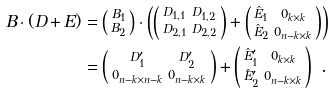Convert formula to latex. <formula><loc_0><loc_0><loc_500><loc_500>B \cdot ( D + E ) & = \left ( \begin{smallmatrix} B _ { 1 } \\ B _ { 2 } \end{smallmatrix} \right ) \cdot \left ( \left ( \begin{smallmatrix} D _ { 1 , 1 } & D _ { 1 , 2 } \\ D _ { 2 , 1 } & D _ { 2 , 2 } \end{smallmatrix} \right ) + \left ( \begin{smallmatrix} \hat { E } _ { 1 } & 0 _ { k \times k } \\ \hat { E } _ { 2 } & 0 _ { n - k \times k } \end{smallmatrix} \right ) \right ) \\ & = \left ( \begin{smallmatrix} D _ { 1 } ^ { \prime } & D _ { 2 } ^ { \prime } \\ 0 _ { n - k \times n - k } & 0 _ { n - k \times k } \end{smallmatrix} \right ) + \left ( \begin{smallmatrix} \hat { E } _ { 1 } ^ { \prime } & 0 _ { k \times k } \\ \hat { E } _ { 2 } ^ { \prime } & 0 _ { n - k \times k } \end{smallmatrix} \right ) \ .</formula> 